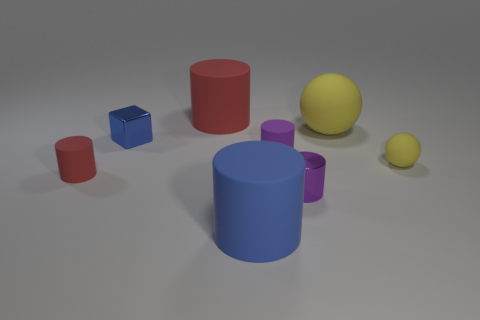Subtract all blue cylinders. How many cylinders are left? 4 Subtract all large blue cylinders. How many cylinders are left? 4 Subtract all cyan cylinders. Subtract all cyan cubes. How many cylinders are left? 5 Add 1 small red cylinders. How many objects exist? 9 Subtract all spheres. How many objects are left? 6 Add 2 blue metallic cubes. How many blue metallic cubes exist? 3 Subtract 0 blue balls. How many objects are left? 8 Subtract all blue rubber things. Subtract all yellow objects. How many objects are left? 5 Add 1 small yellow matte things. How many small yellow matte things are left? 2 